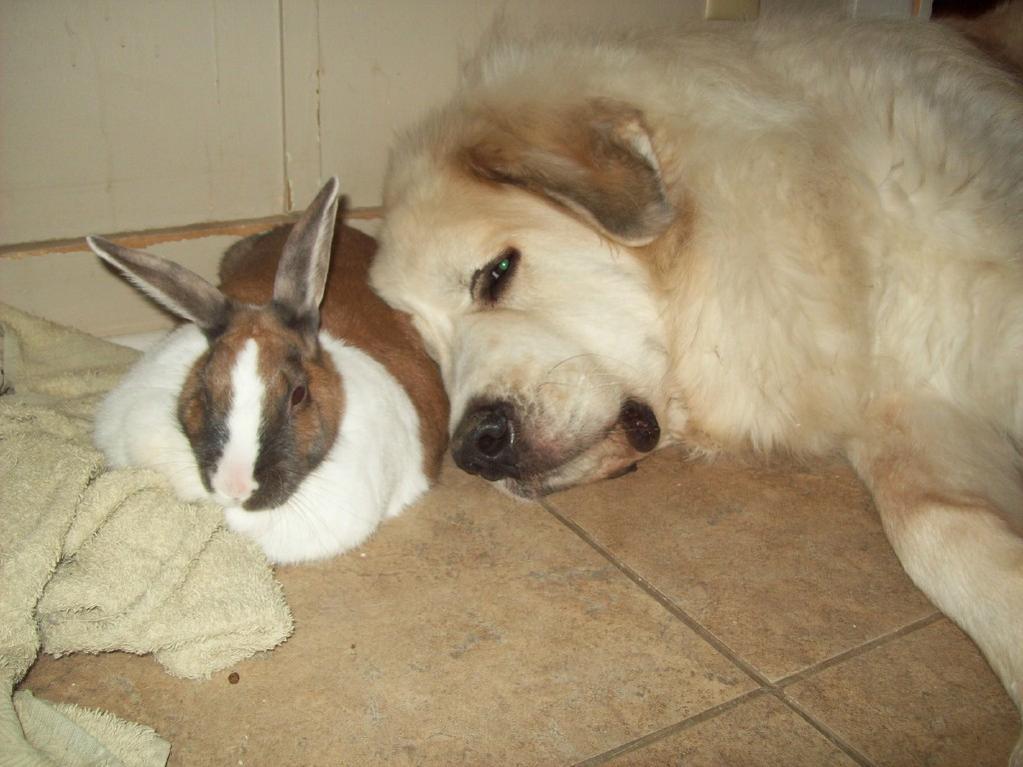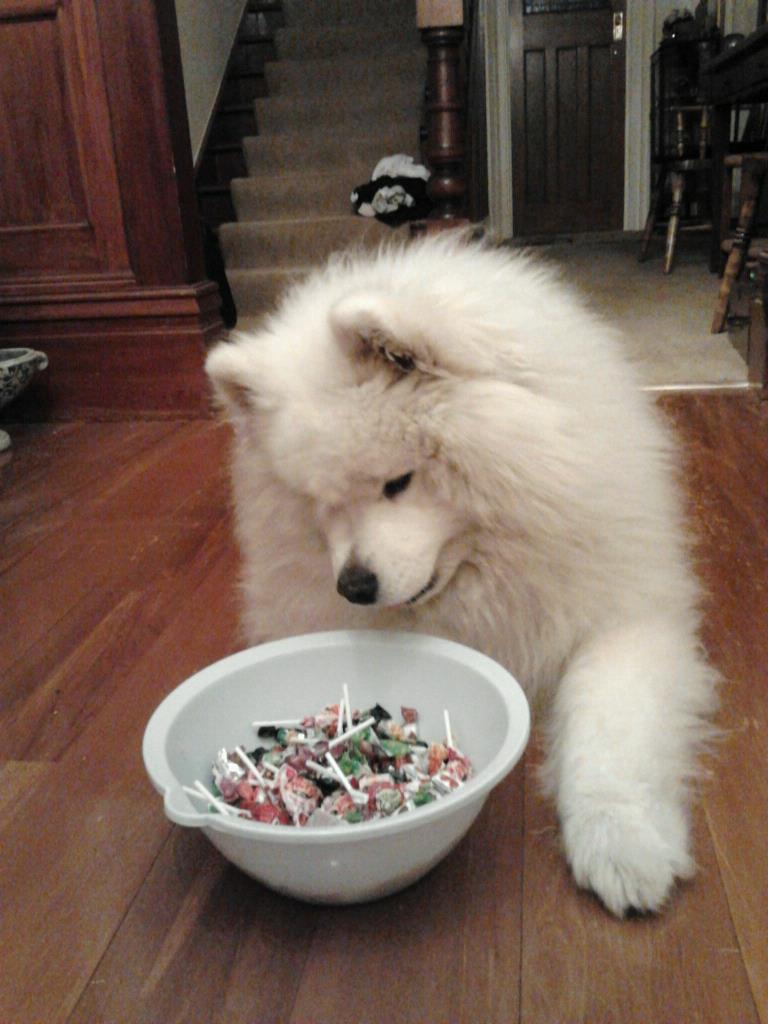The first image is the image on the left, the second image is the image on the right. Examine the images to the left and right. Is the description "One image features a rabbit next to a dog." accurate? Answer yes or no. Yes. The first image is the image on the left, the second image is the image on the right. Evaluate the accuracy of this statement regarding the images: "The left image contains a dog interacting with a rabbit.". Is it true? Answer yes or no. Yes. 